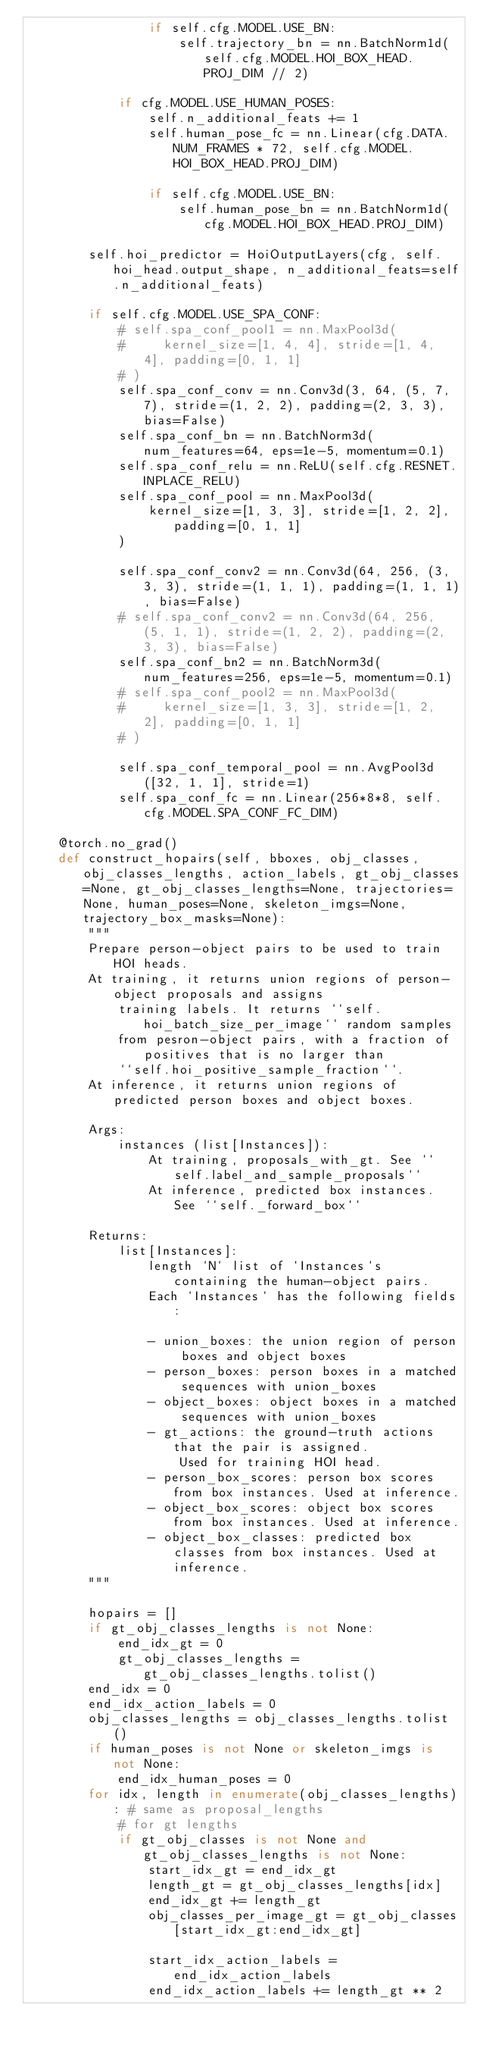<code> <loc_0><loc_0><loc_500><loc_500><_Python_>                if self.cfg.MODEL.USE_BN:
                    self.trajectory_bn = nn.BatchNorm1d(self.cfg.MODEL.HOI_BOX_HEAD.PROJ_DIM // 2)
            
            if cfg.MODEL.USE_HUMAN_POSES:
                self.n_additional_feats += 1
                self.human_pose_fc = nn.Linear(cfg.DATA.NUM_FRAMES * 72, self.cfg.MODEL.HOI_BOX_HEAD.PROJ_DIM)

                if self.cfg.MODEL.USE_BN:
                    self.human_pose_bn = nn.BatchNorm1d(cfg.MODEL.HOI_BOX_HEAD.PROJ_DIM)

        self.hoi_predictor = HoiOutputLayers(cfg, self.hoi_head.output_shape, n_additional_feats=self.n_additional_feats)

        if self.cfg.MODEL.USE_SPA_CONF:
            # self.spa_conf_pool1 = nn.MaxPool3d(
            #     kernel_size=[1, 4, 4], stride=[1, 4, 4], padding=[0, 1, 1]
            # )
            self.spa_conf_conv = nn.Conv3d(3, 64, (5, 7, 7), stride=(1, 2, 2), padding=(2, 3, 3), bias=False)
            self.spa_conf_bn = nn.BatchNorm3d(num_features=64, eps=1e-5, momentum=0.1)
            self.spa_conf_relu = nn.ReLU(self.cfg.RESNET.INPLACE_RELU)
            self.spa_conf_pool = nn.MaxPool3d(
                kernel_size=[1, 3, 3], stride=[1, 2, 2], padding=[0, 1, 1]
            )
            
            self.spa_conf_conv2 = nn.Conv3d(64, 256, (3, 3, 3), stride=(1, 1, 1), padding=(1, 1, 1), bias=False)
            # self.spa_conf_conv2 = nn.Conv3d(64, 256, (5, 1, 1), stride=(1, 2, 2), padding=(2, 3, 3), bias=False)
            self.spa_conf_bn2 = nn.BatchNorm3d(num_features=256, eps=1e-5, momentum=0.1)
            # self.spa_conf_pool2 = nn.MaxPool3d(
            #     kernel_size=[1, 3, 3], stride=[1, 2, 2], padding=[0, 1, 1]
            # )

            self.spa_conf_temporal_pool = nn.AvgPool3d([32, 1, 1], stride=1)
            self.spa_conf_fc = nn.Linear(256*8*8, self.cfg.MODEL.SPA_CONF_FC_DIM)

    @torch.no_grad()
    def construct_hopairs(self, bboxes, obj_classes, obj_classes_lengths, action_labels, gt_obj_classes=None, gt_obj_classes_lengths=None, trajectories=None, human_poses=None, skeleton_imgs=None, trajectory_box_masks=None):
        """
        Prepare person-object pairs to be used to train HOI heads.
        At training, it returns union regions of person-object proposals and assigns
            training labels. It returns ``self.hoi_batch_size_per_image`` random samples
            from pesron-object pairs, with a fraction of positives that is no larger than
            ``self.hoi_positive_sample_fraction``.
        At inference, it returns union regions of predicted person boxes and object boxes.

        Args:
            instances (list[Instances]):
                At training, proposals_with_gt. See ``self.label_and_sample_proposals``
                At inference, predicted box instances. See ``self._forward_box``

        Returns:
            list[Instances]:
                length `N` list of `Instances`s containing the human-object pairs.
                Each `Instances` has the following fields:

                - union_boxes: the union region of person boxes and object boxes
                - person_boxes: person boxes in a matched sequences with union_boxes
                - object_boxes: object boxes in a matched sequences with union_boxes
                - gt_actions: the ground-truth actions that the pair is assigned.
                    Used for training HOI head.
                - person_box_scores: person box scores from box instances. Used at inference.
                - object_box_scores: object box scores from box instances. Used at inference.
                - object_box_classes: predicted box classes from box instances. Used at inference.
        """
        
        hopairs = []
        if gt_obj_classes_lengths is not None:
            end_idx_gt = 0
            gt_obj_classes_lengths = gt_obj_classes_lengths.tolist()
        end_idx = 0
        end_idx_action_labels = 0
        obj_classes_lengths = obj_classes_lengths.tolist()
        if human_poses is not None or skeleton_imgs is not None:
            end_idx_human_poses = 0
        for idx, length in enumerate(obj_classes_lengths): # same as proposal_lengths
            # for gt lengths
            if gt_obj_classes is not None and gt_obj_classes_lengths is not None:
                start_idx_gt = end_idx_gt
                length_gt = gt_obj_classes_lengths[idx]
                end_idx_gt += length_gt
                obj_classes_per_image_gt = gt_obj_classes[start_idx_gt:end_idx_gt]

                start_idx_action_labels = end_idx_action_labels
                end_idx_action_labels += length_gt ** 2</code> 